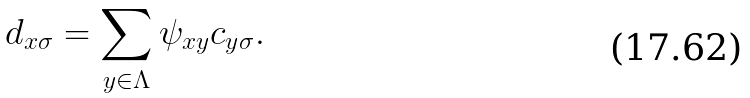<formula> <loc_0><loc_0><loc_500><loc_500>d _ { x \sigma } = \sum _ { y \in \Lambda } \psi _ { x y } c _ { y \sigma } .</formula> 